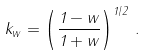<formula> <loc_0><loc_0><loc_500><loc_500>k _ { w } = \left ( \frac { 1 - w } { 1 + w } \right ) ^ { 1 / 2 } \, .</formula> 